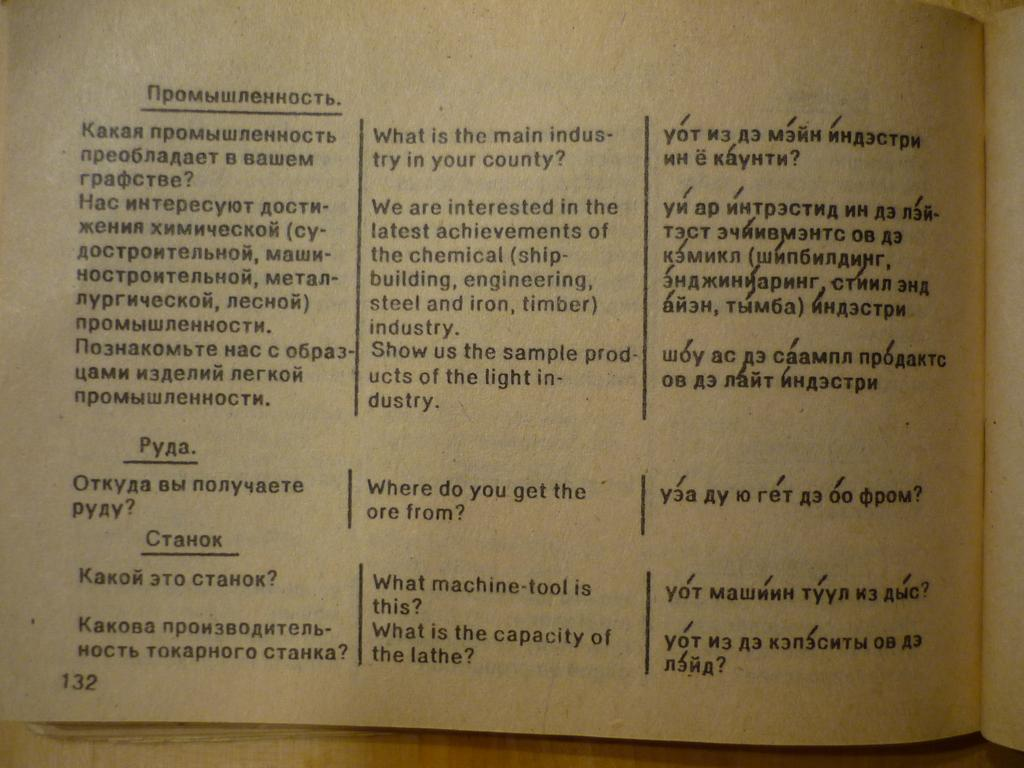Provide a one-sentence caption for the provided image. On epage of an Russian to English dictionary looks quite old and worn. 